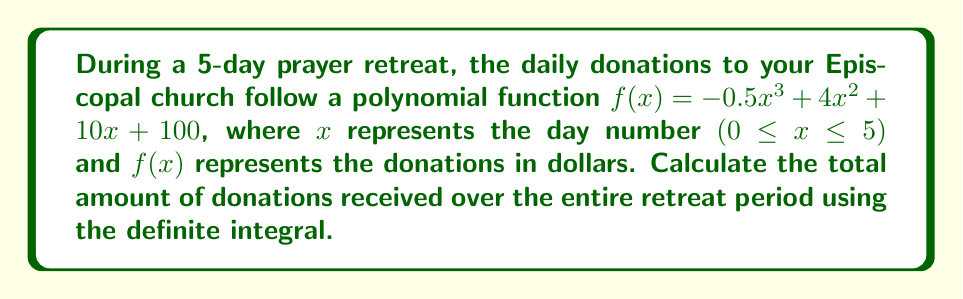What is the answer to this math problem? To find the total donations over the 5-day period, we need to calculate the area under the curve of $f(x)$ from $x=0$ to $x=5$. This can be done using a definite integral.

Step 1: Set up the definite integral
$$\int_0^5 (-0.5x^3 + 4x^2 + 10x + 100) dx$$

Step 2: Integrate the polynomial term by term
$$\left[ -0.5 \cdot \frac{x^4}{4} + 4 \cdot \frac{x^3}{3} + 10 \cdot \frac{x^2}{2} + 100x \right]_0^5$$

Step 3: Evaluate the antiderivative at the upper and lower bounds
Upper bound (x = 5):
$$-0.5 \cdot \frac{5^4}{4} + 4 \cdot \frac{5^3}{3} + 10 \cdot \frac{5^2}{2} + 100 \cdot 5$$
$$= -78.125 + 166.67 + 125 + 500 = 713.54$$

Lower bound (x = 0):
$$-0.5 \cdot \frac{0^4}{4} + 4 \cdot \frac{0^3}{3} + 10 \cdot \frac{0^2}{2} + 100 \cdot 0 = 0$$

Step 4: Subtract the lower bound from the upper bound
$$713.54 - 0 = 713.54$$

Therefore, the total amount of donations received over the 5-day retreat is $713.54.
Answer: $713.54 